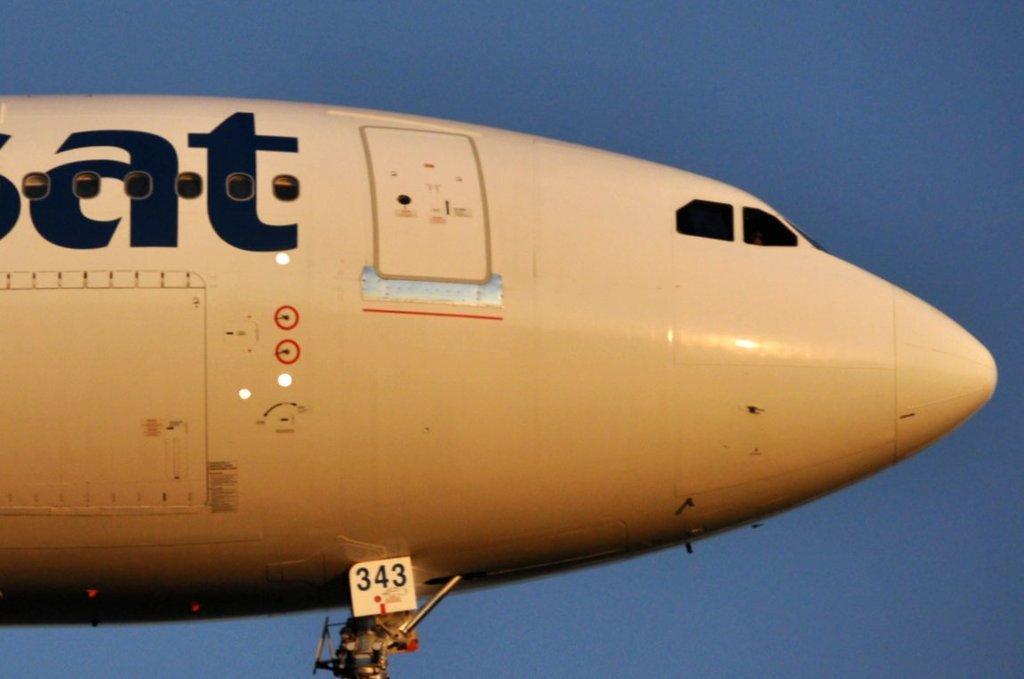Describe this image in one or two sentences. In this image we can see an aeroplane flying in the sky. 